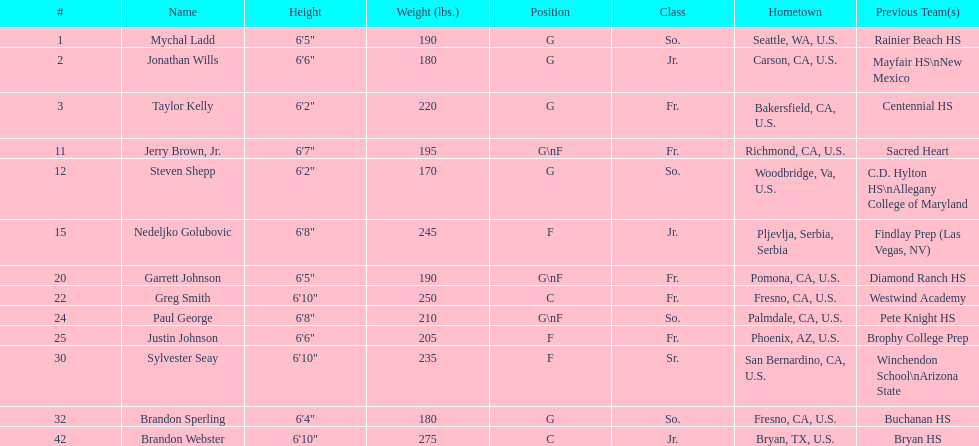How many players consist of both guard (g) and forward (f) positions? 3. 